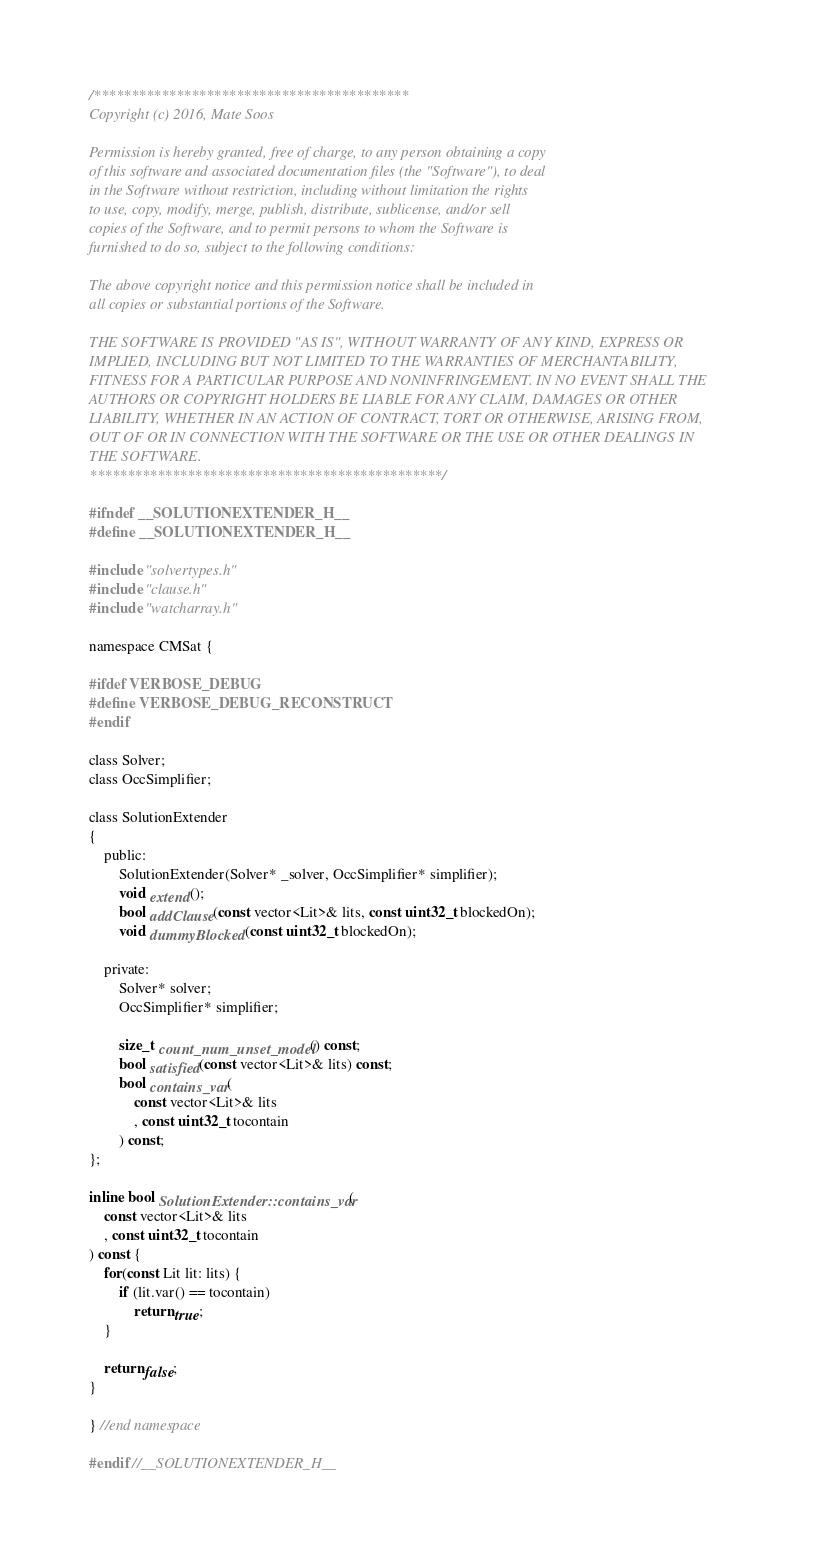<code> <loc_0><loc_0><loc_500><loc_500><_C_>/******************************************
Copyright (c) 2016, Mate Soos

Permission is hereby granted, free of charge, to any person obtaining a copy
of this software and associated documentation files (the "Software"), to deal
in the Software without restriction, including without limitation the rights
to use, copy, modify, merge, publish, distribute, sublicense, and/or sell
copies of the Software, and to permit persons to whom the Software is
furnished to do so, subject to the following conditions:

The above copyright notice and this permission notice shall be included in
all copies or substantial portions of the Software.

THE SOFTWARE IS PROVIDED "AS IS", WITHOUT WARRANTY OF ANY KIND, EXPRESS OR
IMPLIED, INCLUDING BUT NOT LIMITED TO THE WARRANTIES OF MERCHANTABILITY,
FITNESS FOR A PARTICULAR PURPOSE AND NONINFRINGEMENT. IN NO EVENT SHALL THE
AUTHORS OR COPYRIGHT HOLDERS BE LIABLE FOR ANY CLAIM, DAMAGES OR OTHER
LIABILITY, WHETHER IN AN ACTION OF CONTRACT, TORT OR OTHERWISE, ARISING FROM,
OUT OF OR IN CONNECTION WITH THE SOFTWARE OR THE USE OR OTHER DEALINGS IN
THE SOFTWARE.
***********************************************/

#ifndef __SOLUTIONEXTENDER_H__
#define __SOLUTIONEXTENDER_H__

#include "solvertypes.h"
#include "clause.h"
#include "watcharray.h"

namespace CMSat {

#ifdef VERBOSE_DEBUG
#define VERBOSE_DEBUG_RECONSTRUCT
#endif

class Solver;
class OccSimplifier;

class SolutionExtender
{
    public:
        SolutionExtender(Solver* _solver, OccSimplifier* simplifier);
        void extend();
        bool addClause(const vector<Lit>& lits, const uint32_t blockedOn);
        void dummyBlocked(const uint32_t blockedOn);

    private:
        Solver* solver;
        OccSimplifier* simplifier;

        size_t count_num_unset_model() const;
        bool satisfied(const vector<Lit>& lits) const;
        bool contains_var(
            const vector<Lit>& lits
            , const uint32_t tocontain
        ) const;
};

inline bool SolutionExtender::contains_var(
    const vector<Lit>& lits
    , const uint32_t tocontain
) const {
    for(const Lit lit: lits) {
        if (lit.var() == tocontain)
            return true;
    }

    return false;
}

} //end namespace

#endif //__SOLUTIONEXTENDER_H__
</code> 